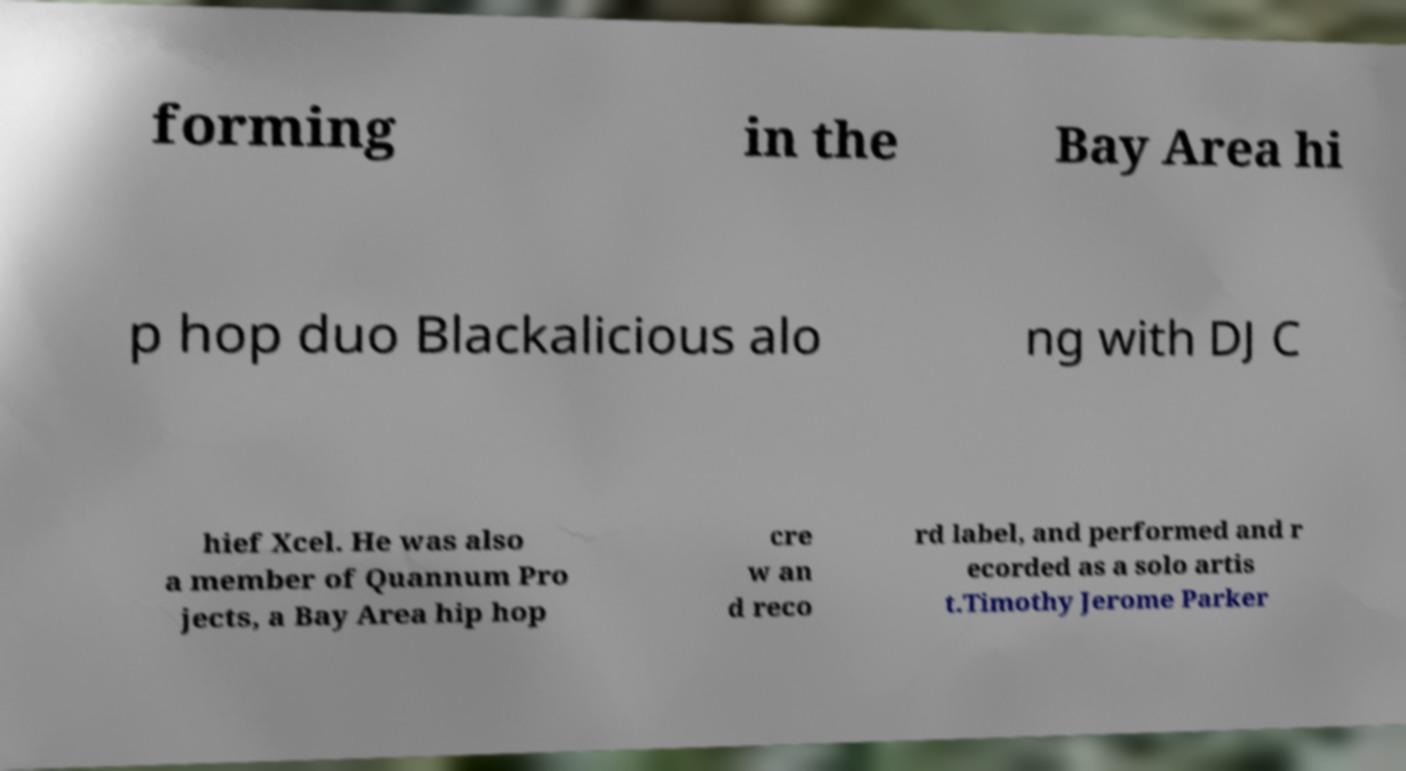Can you accurately transcribe the text from the provided image for me? forming in the Bay Area hi p hop duo Blackalicious alo ng with DJ C hief Xcel. He was also a member of Quannum Pro jects, a Bay Area hip hop cre w an d reco rd label, and performed and r ecorded as a solo artis t.Timothy Jerome Parker 